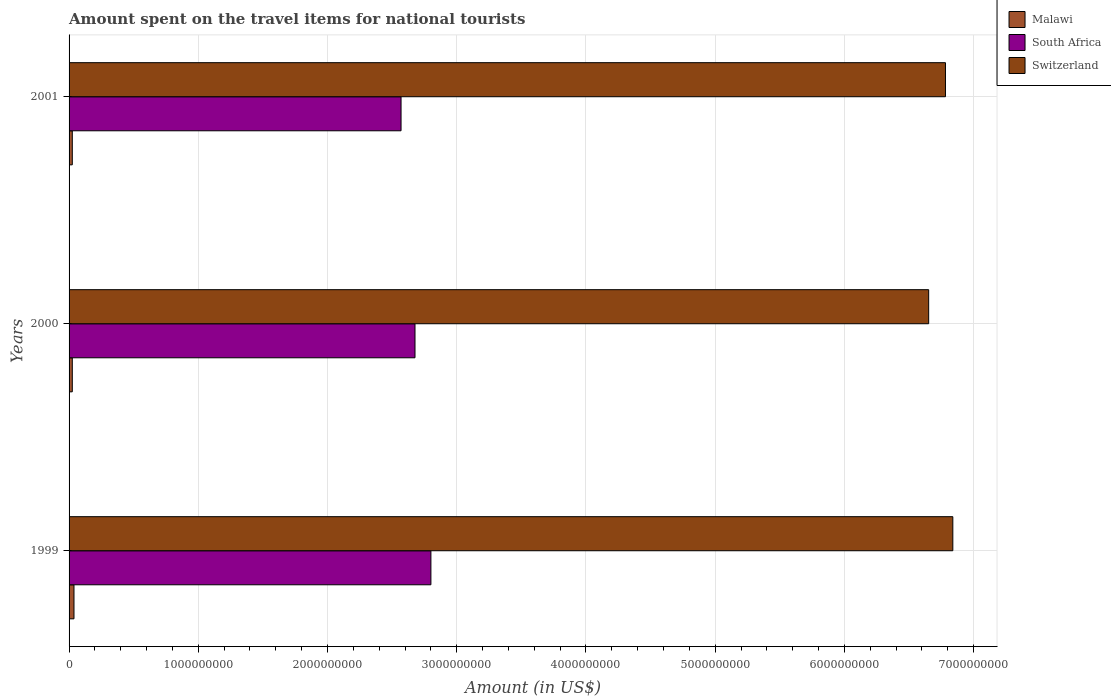How many different coloured bars are there?
Provide a short and direct response. 3. How many groups of bars are there?
Ensure brevity in your answer.  3. What is the label of the 1st group of bars from the top?
Make the answer very short. 2001. What is the amount spent on the travel items for national tourists in Switzerland in 1999?
Your answer should be compact. 6.84e+09. Across all years, what is the maximum amount spent on the travel items for national tourists in Malawi?
Give a very brief answer. 3.80e+07. Across all years, what is the minimum amount spent on the travel items for national tourists in Switzerland?
Offer a terse response. 6.65e+09. In which year was the amount spent on the travel items for national tourists in South Africa minimum?
Keep it short and to the point. 2001. What is the total amount spent on the travel items for national tourists in Switzerland in the graph?
Offer a terse response. 2.03e+1. What is the difference between the amount spent on the travel items for national tourists in Malawi in 1999 and that in 2000?
Provide a succinct answer. 1.30e+07. What is the difference between the amount spent on the travel items for national tourists in Switzerland in 2000 and the amount spent on the travel items for national tourists in Malawi in 2001?
Your answer should be compact. 6.63e+09. What is the average amount spent on the travel items for national tourists in South Africa per year?
Provide a short and direct response. 2.68e+09. In the year 2000, what is the difference between the amount spent on the travel items for national tourists in South Africa and amount spent on the travel items for national tourists in Malawi?
Ensure brevity in your answer.  2.65e+09. What is the ratio of the amount spent on the travel items for national tourists in South Africa in 1999 to that in 2000?
Your answer should be very brief. 1.05. Is the amount spent on the travel items for national tourists in Malawi in 2000 less than that in 2001?
Keep it short and to the point. No. Is the difference between the amount spent on the travel items for national tourists in South Africa in 1999 and 2001 greater than the difference between the amount spent on the travel items for national tourists in Malawi in 1999 and 2001?
Offer a terse response. Yes. What is the difference between the highest and the second highest amount spent on the travel items for national tourists in Malawi?
Provide a succinct answer. 1.30e+07. What is the difference between the highest and the lowest amount spent on the travel items for national tourists in Switzerland?
Give a very brief answer. 1.87e+08. Is the sum of the amount spent on the travel items for national tourists in Switzerland in 2000 and 2001 greater than the maximum amount spent on the travel items for national tourists in Malawi across all years?
Your answer should be very brief. Yes. What does the 1st bar from the top in 2001 represents?
Ensure brevity in your answer.  Switzerland. What does the 1st bar from the bottom in 1999 represents?
Ensure brevity in your answer.  Malawi. What is the difference between two consecutive major ticks on the X-axis?
Your response must be concise. 1.00e+09. How many legend labels are there?
Offer a very short reply. 3. What is the title of the graph?
Your response must be concise. Amount spent on the travel items for national tourists. What is the label or title of the X-axis?
Offer a very short reply. Amount (in US$). What is the Amount (in US$) in Malawi in 1999?
Your answer should be compact. 3.80e+07. What is the Amount (in US$) in South Africa in 1999?
Offer a terse response. 2.80e+09. What is the Amount (in US$) in Switzerland in 1999?
Keep it short and to the point. 6.84e+09. What is the Amount (in US$) in Malawi in 2000?
Provide a short and direct response. 2.50e+07. What is the Amount (in US$) of South Africa in 2000?
Your answer should be very brief. 2.68e+09. What is the Amount (in US$) of Switzerland in 2000?
Make the answer very short. 6.65e+09. What is the Amount (in US$) in Malawi in 2001?
Your answer should be compact. 2.50e+07. What is the Amount (in US$) of South Africa in 2001?
Provide a short and direct response. 2.57e+09. What is the Amount (in US$) of Switzerland in 2001?
Provide a short and direct response. 6.78e+09. Across all years, what is the maximum Amount (in US$) of Malawi?
Give a very brief answer. 3.80e+07. Across all years, what is the maximum Amount (in US$) in South Africa?
Provide a succinct answer. 2.80e+09. Across all years, what is the maximum Amount (in US$) in Switzerland?
Your answer should be very brief. 6.84e+09. Across all years, what is the minimum Amount (in US$) of Malawi?
Provide a short and direct response. 2.50e+07. Across all years, what is the minimum Amount (in US$) of South Africa?
Give a very brief answer. 2.57e+09. Across all years, what is the minimum Amount (in US$) in Switzerland?
Your answer should be very brief. 6.65e+09. What is the total Amount (in US$) of Malawi in the graph?
Make the answer very short. 8.80e+07. What is the total Amount (in US$) in South Africa in the graph?
Provide a succinct answer. 8.05e+09. What is the total Amount (in US$) of Switzerland in the graph?
Ensure brevity in your answer.  2.03e+1. What is the difference between the Amount (in US$) in Malawi in 1999 and that in 2000?
Offer a very short reply. 1.30e+07. What is the difference between the Amount (in US$) in South Africa in 1999 and that in 2000?
Provide a succinct answer. 1.23e+08. What is the difference between the Amount (in US$) of Switzerland in 1999 and that in 2000?
Make the answer very short. 1.87e+08. What is the difference between the Amount (in US$) of Malawi in 1999 and that in 2001?
Your answer should be very brief. 1.30e+07. What is the difference between the Amount (in US$) of South Africa in 1999 and that in 2001?
Offer a very short reply. 2.31e+08. What is the difference between the Amount (in US$) in Switzerland in 1999 and that in 2001?
Your answer should be very brief. 5.70e+07. What is the difference between the Amount (in US$) in South Africa in 2000 and that in 2001?
Keep it short and to the point. 1.08e+08. What is the difference between the Amount (in US$) of Switzerland in 2000 and that in 2001?
Give a very brief answer. -1.30e+08. What is the difference between the Amount (in US$) in Malawi in 1999 and the Amount (in US$) in South Africa in 2000?
Ensure brevity in your answer.  -2.64e+09. What is the difference between the Amount (in US$) of Malawi in 1999 and the Amount (in US$) of Switzerland in 2000?
Provide a short and direct response. -6.61e+09. What is the difference between the Amount (in US$) in South Africa in 1999 and the Amount (in US$) in Switzerland in 2000?
Offer a very short reply. -3.85e+09. What is the difference between the Amount (in US$) of Malawi in 1999 and the Amount (in US$) of South Africa in 2001?
Offer a very short reply. -2.53e+09. What is the difference between the Amount (in US$) of Malawi in 1999 and the Amount (in US$) of Switzerland in 2001?
Keep it short and to the point. -6.74e+09. What is the difference between the Amount (in US$) of South Africa in 1999 and the Amount (in US$) of Switzerland in 2001?
Give a very brief answer. -3.98e+09. What is the difference between the Amount (in US$) in Malawi in 2000 and the Amount (in US$) in South Africa in 2001?
Provide a succinct answer. -2.54e+09. What is the difference between the Amount (in US$) in Malawi in 2000 and the Amount (in US$) in Switzerland in 2001?
Ensure brevity in your answer.  -6.76e+09. What is the difference between the Amount (in US$) in South Africa in 2000 and the Amount (in US$) in Switzerland in 2001?
Provide a short and direct response. -4.10e+09. What is the average Amount (in US$) in Malawi per year?
Offer a very short reply. 2.93e+07. What is the average Amount (in US$) of South Africa per year?
Your response must be concise. 2.68e+09. What is the average Amount (in US$) of Switzerland per year?
Make the answer very short. 6.76e+09. In the year 1999, what is the difference between the Amount (in US$) of Malawi and Amount (in US$) of South Africa?
Your response must be concise. -2.76e+09. In the year 1999, what is the difference between the Amount (in US$) in Malawi and Amount (in US$) in Switzerland?
Keep it short and to the point. -6.80e+09. In the year 1999, what is the difference between the Amount (in US$) in South Africa and Amount (in US$) in Switzerland?
Your answer should be very brief. -4.04e+09. In the year 2000, what is the difference between the Amount (in US$) of Malawi and Amount (in US$) of South Africa?
Make the answer very short. -2.65e+09. In the year 2000, what is the difference between the Amount (in US$) of Malawi and Amount (in US$) of Switzerland?
Provide a short and direct response. -6.63e+09. In the year 2000, what is the difference between the Amount (in US$) of South Africa and Amount (in US$) of Switzerland?
Your answer should be compact. -3.98e+09. In the year 2001, what is the difference between the Amount (in US$) in Malawi and Amount (in US$) in South Africa?
Keep it short and to the point. -2.54e+09. In the year 2001, what is the difference between the Amount (in US$) in Malawi and Amount (in US$) in Switzerland?
Make the answer very short. -6.76e+09. In the year 2001, what is the difference between the Amount (in US$) in South Africa and Amount (in US$) in Switzerland?
Offer a very short reply. -4.21e+09. What is the ratio of the Amount (in US$) in Malawi in 1999 to that in 2000?
Your response must be concise. 1.52. What is the ratio of the Amount (in US$) of South Africa in 1999 to that in 2000?
Your response must be concise. 1.05. What is the ratio of the Amount (in US$) in Switzerland in 1999 to that in 2000?
Your response must be concise. 1.03. What is the ratio of the Amount (in US$) of Malawi in 1999 to that in 2001?
Your answer should be very brief. 1.52. What is the ratio of the Amount (in US$) in South Africa in 1999 to that in 2001?
Offer a very short reply. 1.09. What is the ratio of the Amount (in US$) in Switzerland in 1999 to that in 2001?
Offer a very short reply. 1.01. What is the ratio of the Amount (in US$) of South Africa in 2000 to that in 2001?
Provide a succinct answer. 1.04. What is the ratio of the Amount (in US$) of Switzerland in 2000 to that in 2001?
Offer a terse response. 0.98. What is the difference between the highest and the second highest Amount (in US$) in Malawi?
Provide a succinct answer. 1.30e+07. What is the difference between the highest and the second highest Amount (in US$) of South Africa?
Offer a terse response. 1.23e+08. What is the difference between the highest and the second highest Amount (in US$) in Switzerland?
Offer a terse response. 5.70e+07. What is the difference between the highest and the lowest Amount (in US$) of Malawi?
Make the answer very short. 1.30e+07. What is the difference between the highest and the lowest Amount (in US$) in South Africa?
Offer a terse response. 2.31e+08. What is the difference between the highest and the lowest Amount (in US$) of Switzerland?
Offer a very short reply. 1.87e+08. 